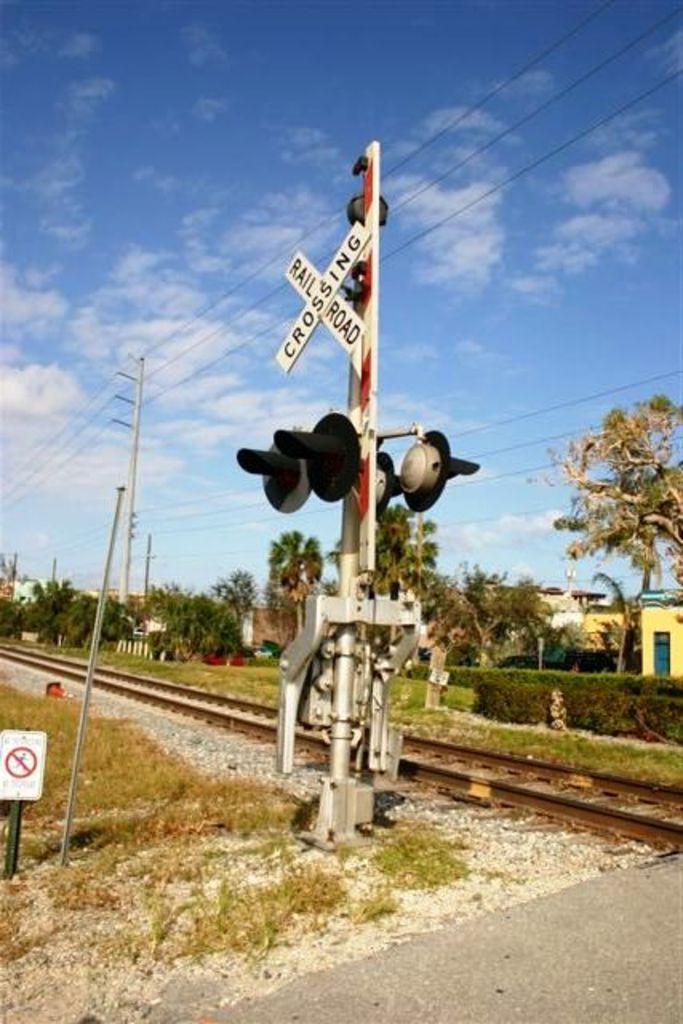What type of crossing is this?
Your response must be concise. Railroad. What kind of crossing?
Offer a very short reply. Railroad. 